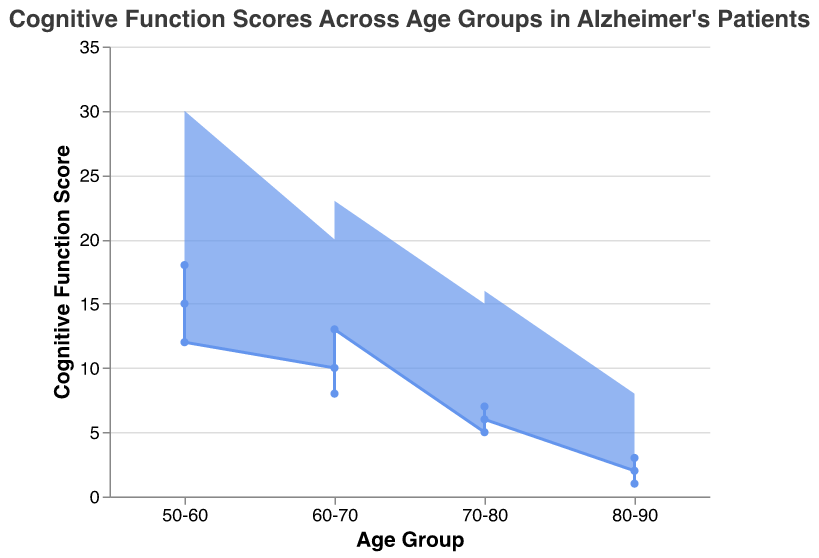What is the title of the chart? The title is displayed at the top of the chart and serves as a summary of what the chart represents. In this case, it captures the essence of the data being visualized.
Answer: Cognitive Function Scores Across Age Groups in Alzheimer's Patients What is the age group with the lowest minimum cognitive function score? By examining the plot for the age group with the lowest end of the range on the y-axis, we can determine the minimum score value across all age groups.
Answer: 80-90 What is the average maximum cognitive function score for the 50-60 age group? First, identify the maximum scores for the 50-60 age group: 25, 22, and 30. Then, sum these scores (25 + 22 + 30 = 77) and divide by the number of data points (77 / 3).
Answer: 25.67 Which age group shows the largest range in cognitive function scores? Calculate the range for each age group by subtracting the minimum score from the maximum score within each group, then compare to find the largest range. The ranges are:
  - 50-60: Max 30 - Min 12 = 18
  - 60-70: Max 23 - Min 8 = 15
  - 70-80: Max 16 - Min 5 = 11
  - 80-90: Max 10 - Min 1 = 9 
  Therefore, the age group 50-60 has the largest range.
Answer: 50-60 Does the minimum cognitive function score generally decrease with increasing age groups? By visually tracing the line and points from the younger to the older age groups, you can observe a downward trend in the minimum scores across the age groups.
Answer: Yes What is the median of the minimum cognitive function scores in the 60-70 age group? Collect the minimum scores for the 60-70 age group: 10, 8, and 13. Sort these values in ascending order (8, 10, 13). The median is the middle value of this ordered list.
Answer: 10 Between the 70-80 and 80-90 age groups, which one has a higher average minimum cognitive function score? First, calculate the average for each group:
  - 70-80: (5 + 7 + 6) / 3 = 18 / 3 = 6
  - 80-90: (2 + 3 + 1) / 3 = 6 / 3 = 2
  Compare the averages: 6 (70-80) is greater than 2 (80-90).
Answer: 70-80 What pattern can be observed in the variation of cognitive function scores as age increases? By following the change in the range area across age groups, it becomes evident that both minimum and maximum scores tend to decrease, and the range of scores generally narrows.
Answer: Scores decrease and ranges narrow Which age group has the narrowest spread of cognitive function scores? The spread or range can be observed by the distance between the minimum and maximum function scores:
  - 50-60 has a range of 18
  - 60-70 has a range of 15
  - 70-80 has a range of 11
  - 80-90 has a range of 9
  Thus, 80-90 has the narrowest spread.
Answer: 80-90 